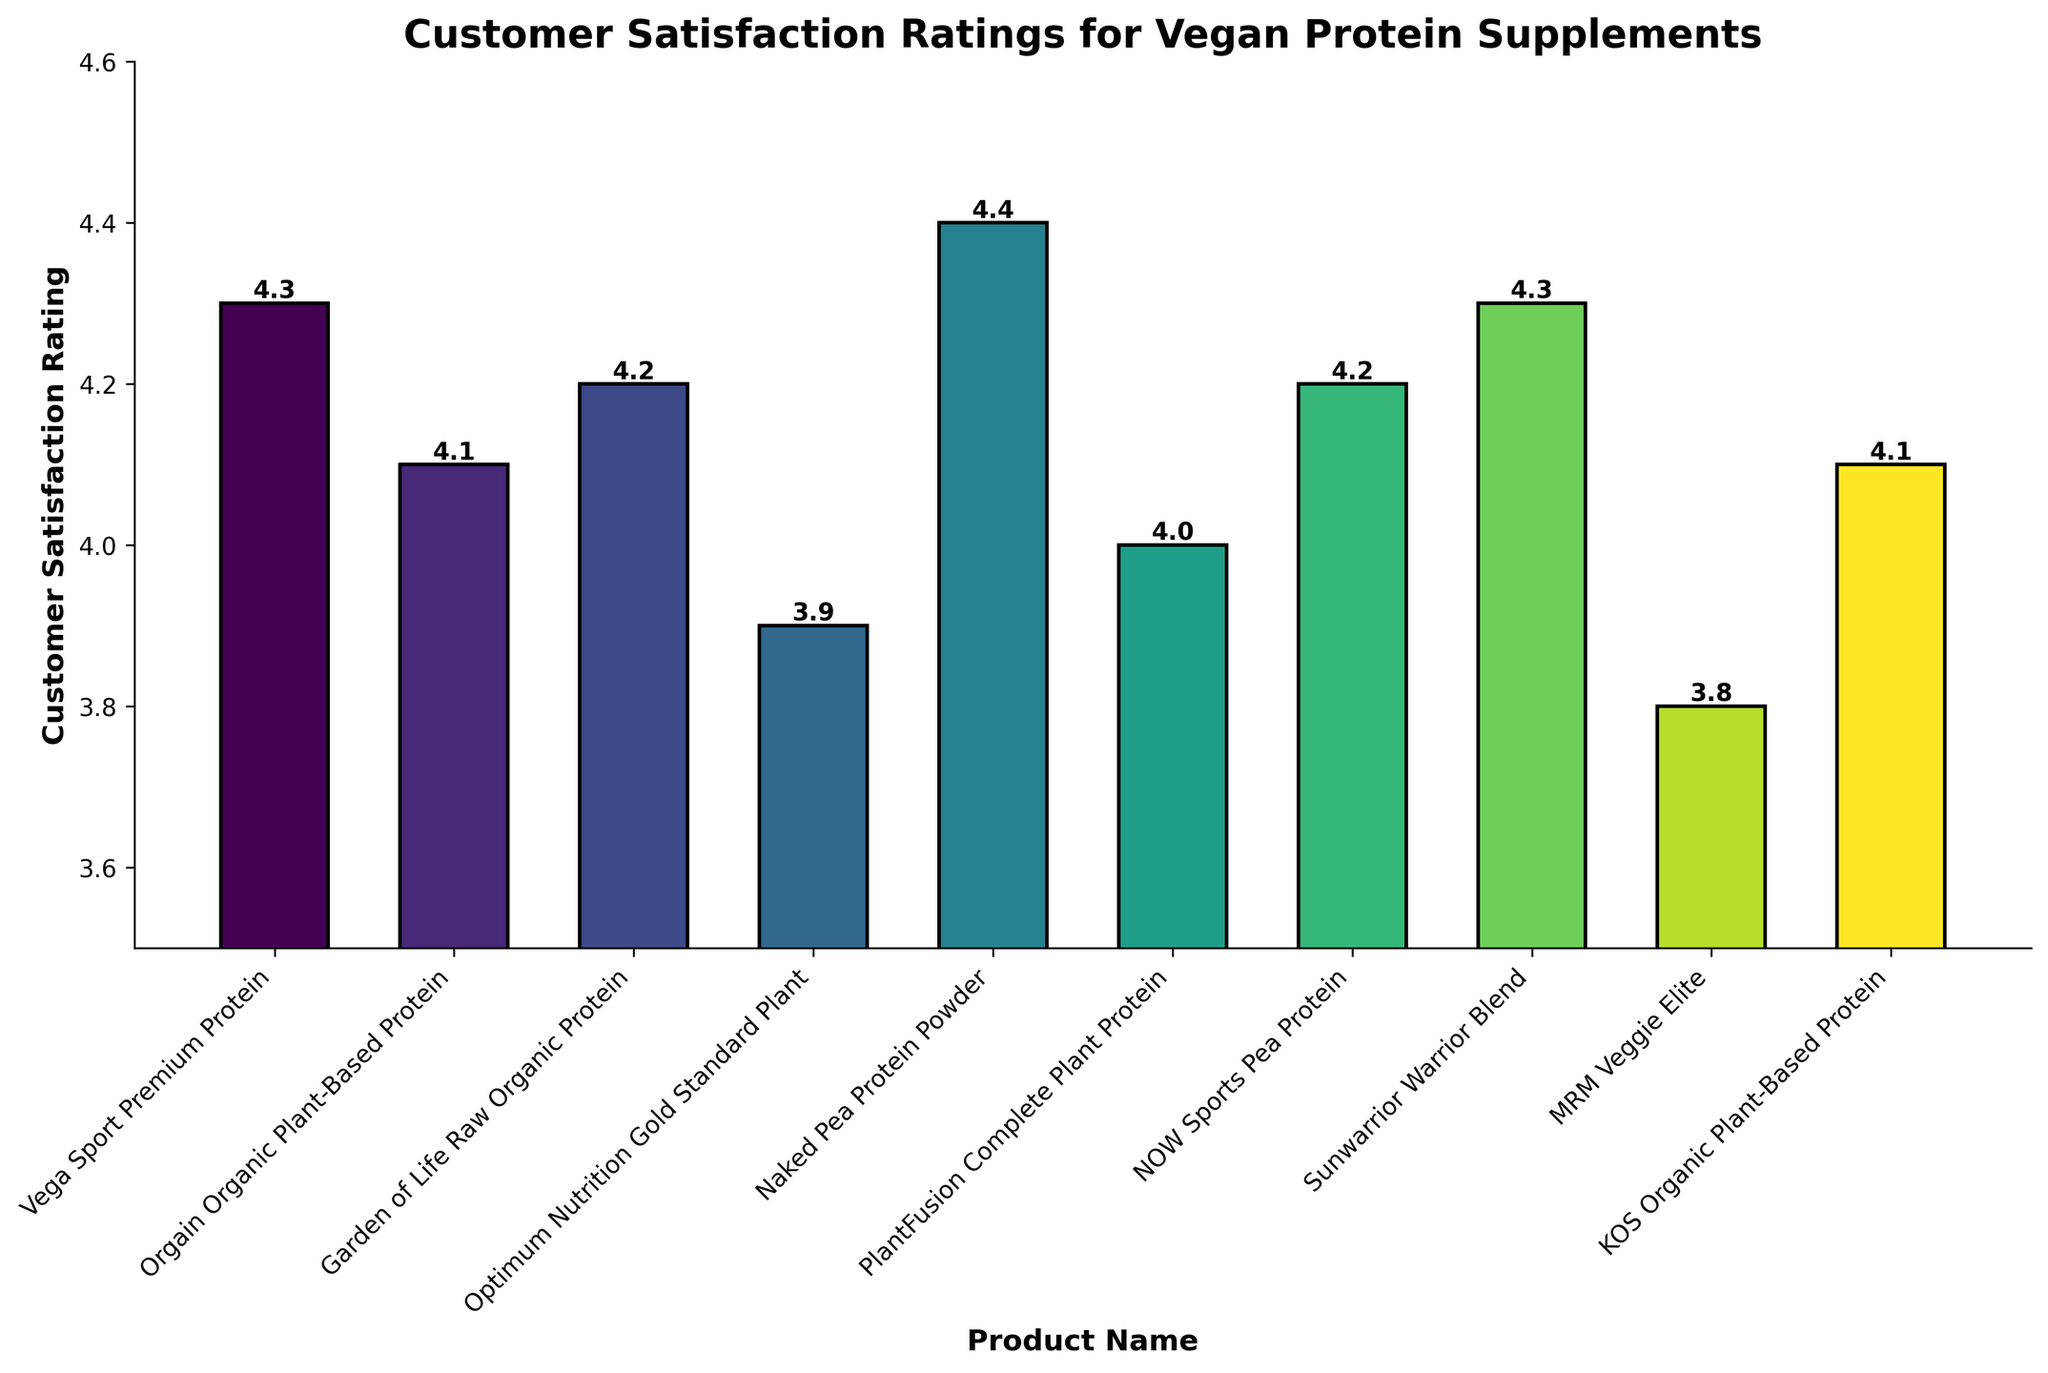How many products have a customer satisfaction rating of 4.2? The bars for Garden of Life Raw Organic Protein and NOW Sports Pea Protein have ratings of 4.2, totaling two products.
Answer: 2 Which product has the highest customer satisfaction rating? The Naked Pea Protein Powder bar reaches the highest point on the y-axis, with a rating of 4.4.
Answer: Naked Pea Protein Powder Which product has a lower customer satisfaction rating than KOS Organic Plant-Based Protein but higher than MRM Veggie Elite? Optimum Nutrition Gold Standard Plant has a rating (3.9) that falls between KOS Organic Plant-Based Protein (4.1) and MRM Veggie Elite (3.8).
Answer: Optimum Nutrition Gold Standard Plant Compare the ratings of Vega Sport Premium Protein and Sunwarrior Warrior Blend. Which one is higher? Both bars for Vega Sport Premium Protein and Sunwarrior Warrior Blend have the same height, indicating both have a customer satisfaction rating of 4.3.
Answer: Equal What is the difference in customer satisfaction rating between Naked Pea Protein Powder and MRM Veggie Elite? Naked Pea Protein Powder has a rating of 4.4, and MRM Veggie Elite has a rating of 3.8. The difference is 4.4 - 3.8 = 0.6.
Answer: 0.6 What's the average customer satisfaction rating for the top three rated products? The top three products are Naked Pea Protein Powder (4.4), Vega Sport Premium Protein (4.3), and Sunwarrior Warrior Blend (4.3). The average rating is (4.4 + 4.3 + 4.3) / 3 = 4.33.
Answer: 4.33 How many products have a customer satisfaction rating above 4.0? The bars for products with ratings above 4.0 are Vega Sport Premium Protein (4.3), Orgain Organic Plant-Based Protein (4.1), Garden of Life Raw Organic Protein (4.2), Naked Pea Protein Powder (4.4), NOW Sports Pea Protein (4.2), Sunwarrior Warrior Blend (4.3), and KOS Organic Plant-Based Protein (4.1), totaling seven products.
Answer: 7 